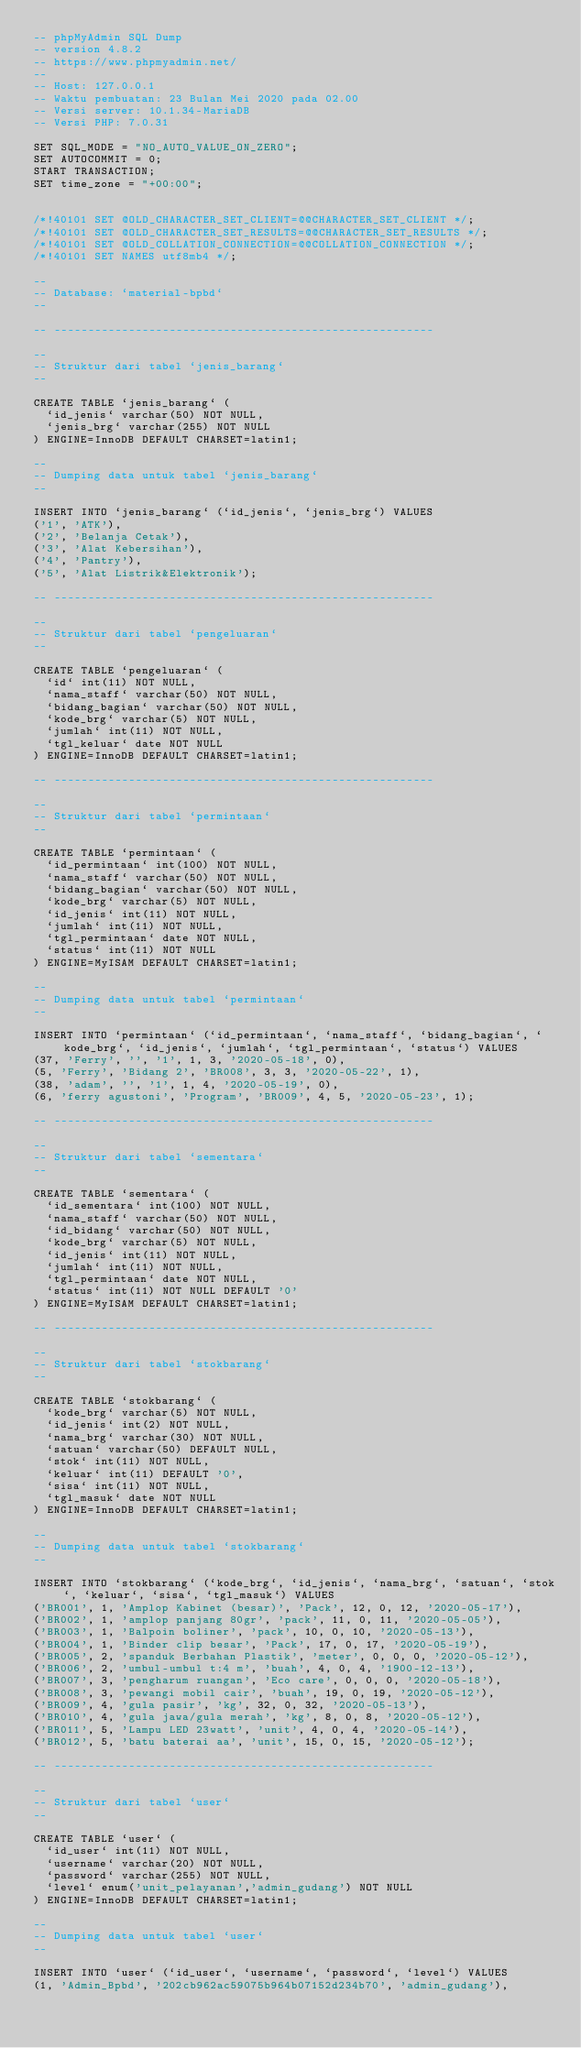Convert code to text. <code><loc_0><loc_0><loc_500><loc_500><_SQL_>-- phpMyAdmin SQL Dump
-- version 4.8.2
-- https://www.phpmyadmin.net/
--
-- Host: 127.0.0.1
-- Waktu pembuatan: 23 Bulan Mei 2020 pada 02.00
-- Versi server: 10.1.34-MariaDB
-- Versi PHP: 7.0.31

SET SQL_MODE = "NO_AUTO_VALUE_ON_ZERO";
SET AUTOCOMMIT = 0;
START TRANSACTION;
SET time_zone = "+00:00";


/*!40101 SET @OLD_CHARACTER_SET_CLIENT=@@CHARACTER_SET_CLIENT */;
/*!40101 SET @OLD_CHARACTER_SET_RESULTS=@@CHARACTER_SET_RESULTS */;
/*!40101 SET @OLD_COLLATION_CONNECTION=@@COLLATION_CONNECTION */;
/*!40101 SET NAMES utf8mb4 */;

--
-- Database: `material-bpbd`
--

-- --------------------------------------------------------

--
-- Struktur dari tabel `jenis_barang`
--

CREATE TABLE `jenis_barang` (
  `id_jenis` varchar(50) NOT NULL,
  `jenis_brg` varchar(255) NOT NULL
) ENGINE=InnoDB DEFAULT CHARSET=latin1;

--
-- Dumping data untuk tabel `jenis_barang`
--

INSERT INTO `jenis_barang` (`id_jenis`, `jenis_brg`) VALUES
('1', 'ATK'),
('2', 'Belanja Cetak'),
('3', 'Alat Kebersihan'),
('4', 'Pantry'),
('5', 'Alat Listrik&Elektronik');

-- --------------------------------------------------------

--
-- Struktur dari tabel `pengeluaran`
--

CREATE TABLE `pengeluaran` (
  `id` int(11) NOT NULL,
  `nama_staff` varchar(50) NOT NULL,
  `bidang_bagian` varchar(50) NOT NULL,
  `kode_brg` varchar(5) NOT NULL,
  `jumlah` int(11) NOT NULL,
  `tgl_keluar` date NOT NULL
) ENGINE=InnoDB DEFAULT CHARSET=latin1;

-- --------------------------------------------------------

--
-- Struktur dari tabel `permintaan`
--

CREATE TABLE `permintaan` (
  `id_permintaan` int(100) NOT NULL,
  `nama_staff` varchar(50) NOT NULL,
  `bidang_bagian` varchar(50) NOT NULL,
  `kode_brg` varchar(5) NOT NULL,
  `id_jenis` int(11) NOT NULL,
  `jumlah` int(11) NOT NULL,
  `tgl_permintaan` date NOT NULL,
  `status` int(11) NOT NULL
) ENGINE=MyISAM DEFAULT CHARSET=latin1;

--
-- Dumping data untuk tabel `permintaan`
--

INSERT INTO `permintaan` (`id_permintaan`, `nama_staff`, `bidang_bagian`, `kode_brg`, `id_jenis`, `jumlah`, `tgl_permintaan`, `status`) VALUES
(37, 'Ferry', '', '1', 1, 3, '2020-05-18', 0),
(5, 'Ferry', 'Bidang 2', 'BR008', 3, 3, '2020-05-22', 1),
(38, 'adam', '', '1', 1, 4, '2020-05-19', 0),
(6, 'ferry agustoni', 'Program', 'BR009', 4, 5, '2020-05-23', 1);

-- --------------------------------------------------------

--
-- Struktur dari tabel `sementara`
--

CREATE TABLE `sementara` (
  `id_sementara` int(100) NOT NULL,
  `nama_staff` varchar(50) NOT NULL,
  `id_bidang` varchar(50) NOT NULL,
  `kode_brg` varchar(5) NOT NULL,
  `id_jenis` int(11) NOT NULL,
  `jumlah` int(11) NOT NULL,
  `tgl_permintaan` date NOT NULL,
  `status` int(11) NOT NULL DEFAULT '0'
) ENGINE=MyISAM DEFAULT CHARSET=latin1;

-- --------------------------------------------------------

--
-- Struktur dari tabel `stokbarang`
--

CREATE TABLE `stokbarang` (
  `kode_brg` varchar(5) NOT NULL,
  `id_jenis` int(2) NOT NULL,
  `nama_brg` varchar(30) NOT NULL,
  `satuan` varchar(50) DEFAULT NULL,
  `stok` int(11) NOT NULL,
  `keluar` int(11) DEFAULT '0',
  `sisa` int(11) NOT NULL,
  `tgl_masuk` date NOT NULL
) ENGINE=InnoDB DEFAULT CHARSET=latin1;

--
-- Dumping data untuk tabel `stokbarang`
--

INSERT INTO `stokbarang` (`kode_brg`, `id_jenis`, `nama_brg`, `satuan`, `stok`, `keluar`, `sisa`, `tgl_masuk`) VALUES
('BR001', 1, 'Amplop Kabinet (besar)', 'Pack', 12, 0, 12, '2020-05-17'),
('BR002', 1, 'amplop panjang 80gr', 'pack', 11, 0, 11, '2020-05-05'),
('BR003', 1, 'Balpoin boliner', 'pack', 10, 0, 10, '2020-05-13'),
('BR004', 1, 'Binder clip besar', 'Pack', 17, 0, 17, '2020-05-19'),
('BR005', 2, 'spanduk Berbahan Plastik', 'meter', 0, 0, 0, '2020-05-12'),
('BR006', 2, 'umbul-umbul t:4 m', 'buah', 4, 0, 4, '1900-12-13'),
('BR007', 3, 'pengharum ruangan', 'Eco care', 0, 0, 0, '2020-05-18'),
('BR008', 3, 'pewangi mobil cair', 'buah', 19, 0, 19, '2020-05-12'),
('BR009', 4, 'gula pasir', 'kg', 32, 0, 32, '2020-05-13'),
('BR010', 4, 'gula jawa/gula merah', 'kg', 8, 0, 8, '2020-05-12'),
('BR011', 5, 'Lampu LED 23watt', 'unit', 4, 0, 4, '2020-05-14'),
('BR012', 5, 'batu baterai aa', 'unit', 15, 0, 15, '2020-05-12');

-- --------------------------------------------------------

--
-- Struktur dari tabel `user`
--

CREATE TABLE `user` (
  `id_user` int(11) NOT NULL,
  `username` varchar(20) NOT NULL,
  `password` varchar(255) NOT NULL,
  `level` enum('unit_pelayanan','admin_gudang') NOT NULL
) ENGINE=InnoDB DEFAULT CHARSET=latin1;

--
-- Dumping data untuk tabel `user`
--

INSERT INTO `user` (`id_user`, `username`, `password`, `level`) VALUES
(1, 'Admin_Bpbd', '202cb962ac59075b964b07152d234b70', 'admin_gudang'),</code> 